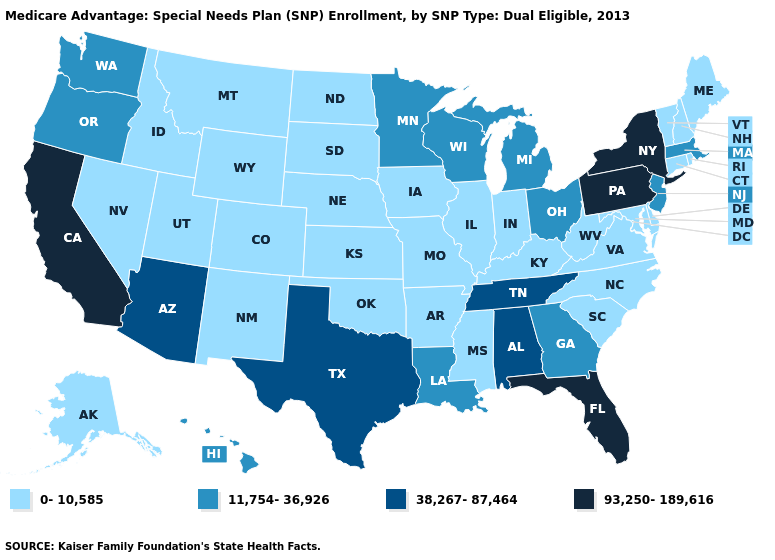What is the value of Georgia?
Answer briefly. 11,754-36,926. Does Pennsylvania have the highest value in the Northeast?
Short answer required. Yes. Which states have the highest value in the USA?
Quick response, please. California, Florida, New York, Pennsylvania. Which states hav the highest value in the South?
Answer briefly. Florida. Is the legend a continuous bar?
Short answer required. No. Name the states that have a value in the range 93,250-189,616?
Be succinct. California, Florida, New York, Pennsylvania. What is the highest value in states that border Idaho?
Concise answer only. 11,754-36,926. What is the highest value in the MidWest ?
Short answer required. 11,754-36,926. Among the states that border Massachusetts , does Vermont have the highest value?
Quick response, please. No. Name the states that have a value in the range 93,250-189,616?
Keep it brief. California, Florida, New York, Pennsylvania. Name the states that have a value in the range 11,754-36,926?
Quick response, please. Georgia, Hawaii, Louisiana, Massachusetts, Michigan, Minnesota, New Jersey, Ohio, Oregon, Washington, Wisconsin. What is the value of Hawaii?
Be succinct. 11,754-36,926. Among the states that border North Dakota , does Montana have the lowest value?
Be succinct. Yes. Name the states that have a value in the range 93,250-189,616?
Keep it brief. California, Florida, New York, Pennsylvania. 